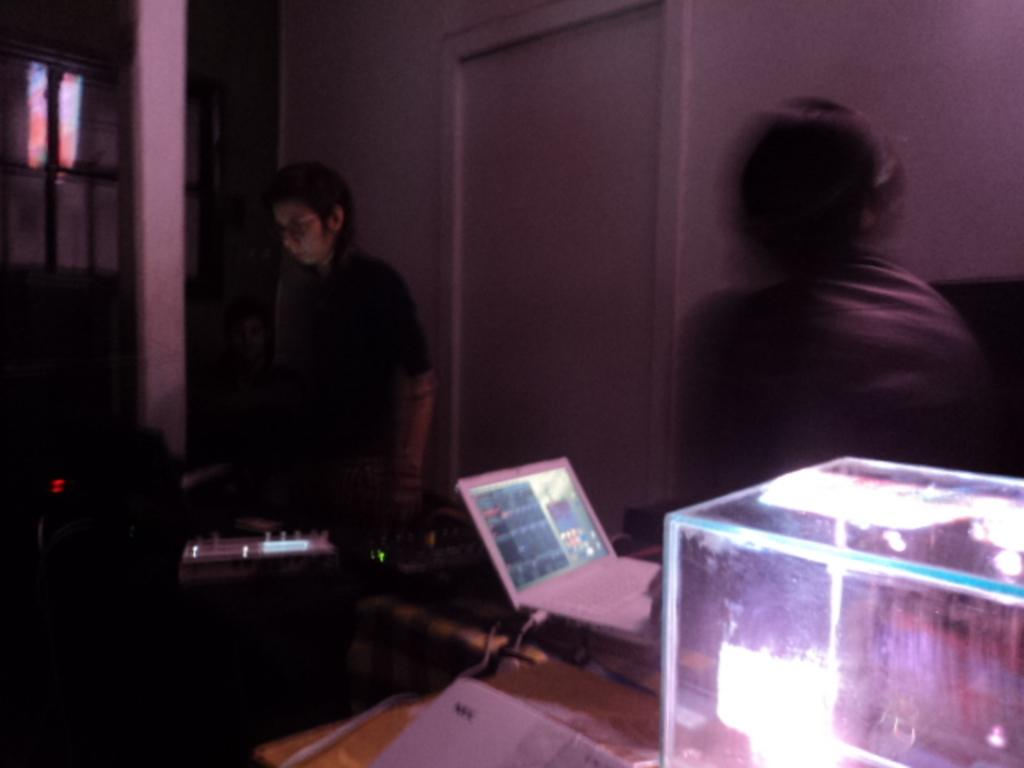What is the overall quality of the image? The image has a blurry view. Who or what can be seen in the image? There are people and objects in the image. What can be seen in the background of the image? The background of the image includes walls, a door, pillars, and a glass window. How much sand can be seen on the calendar in the image? There is no sand or calendar present in the image. What type of ray is visible in the image? There is no ray visible in the image. 